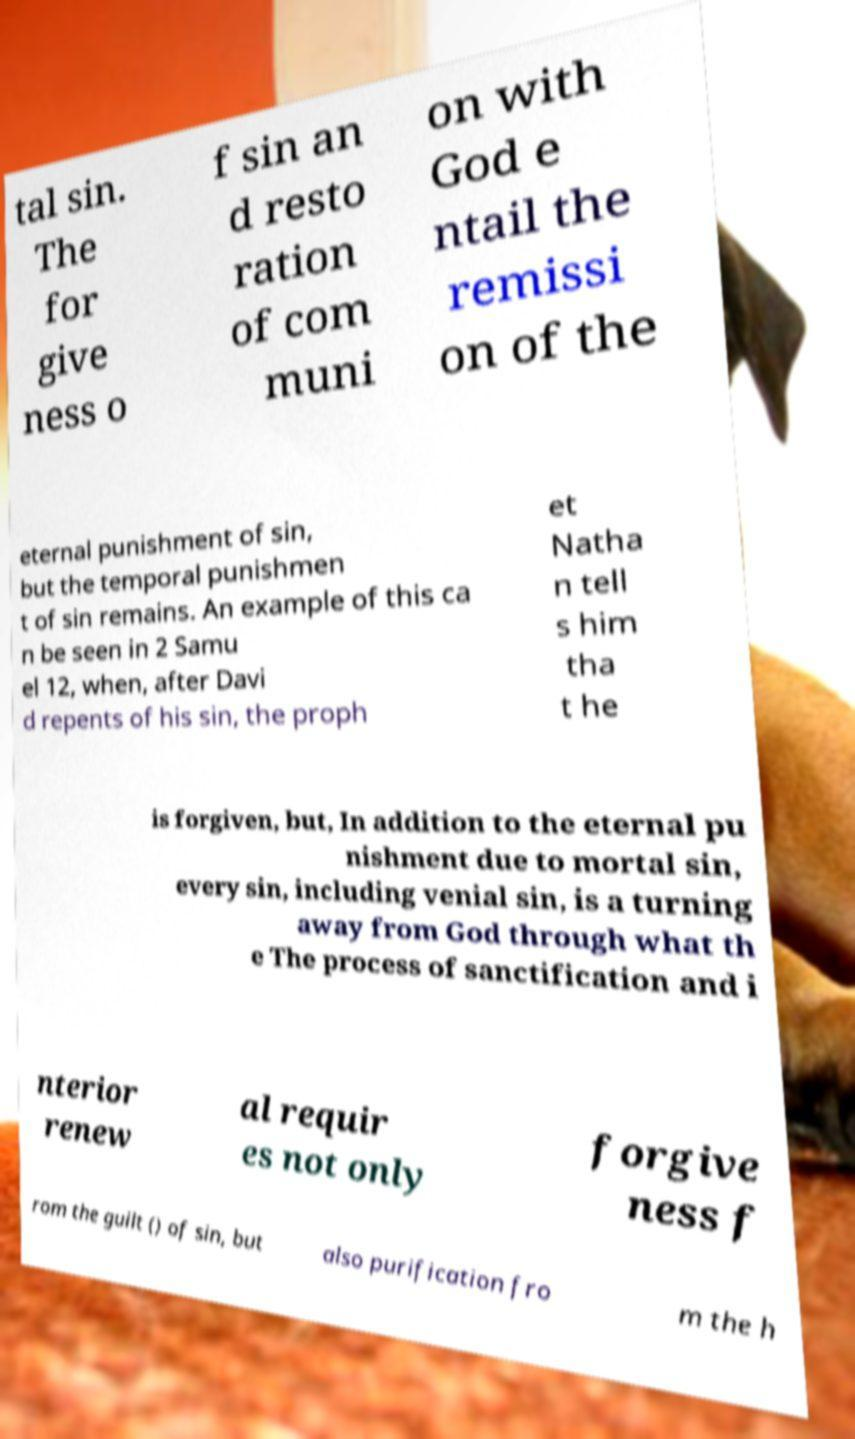Can you accurately transcribe the text from the provided image for me? tal sin. The for give ness o f sin an d resto ration of com muni on with God e ntail the remissi on of the eternal punishment of sin, but the temporal punishmen t of sin remains. An example of this ca n be seen in 2 Samu el 12, when, after Davi d repents of his sin, the proph et Natha n tell s him tha t he is forgiven, but, In addition to the eternal pu nishment due to mortal sin, every sin, including venial sin, is a turning away from God through what th e The process of sanctification and i nterior renew al requir es not only forgive ness f rom the guilt () of sin, but also purification fro m the h 